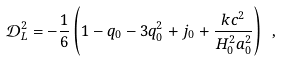<formula> <loc_0><loc_0><loc_500><loc_500>\mathcal { D } _ { L } ^ { 2 } = - \frac { 1 } { 6 } \left ( 1 - q _ { 0 } - 3 q _ { 0 } ^ { 2 } + j _ { 0 } + \frac { k c ^ { 2 } } { H _ { 0 } ^ { 2 } a _ { 0 } ^ { 2 } } \right ) \ ,</formula> 